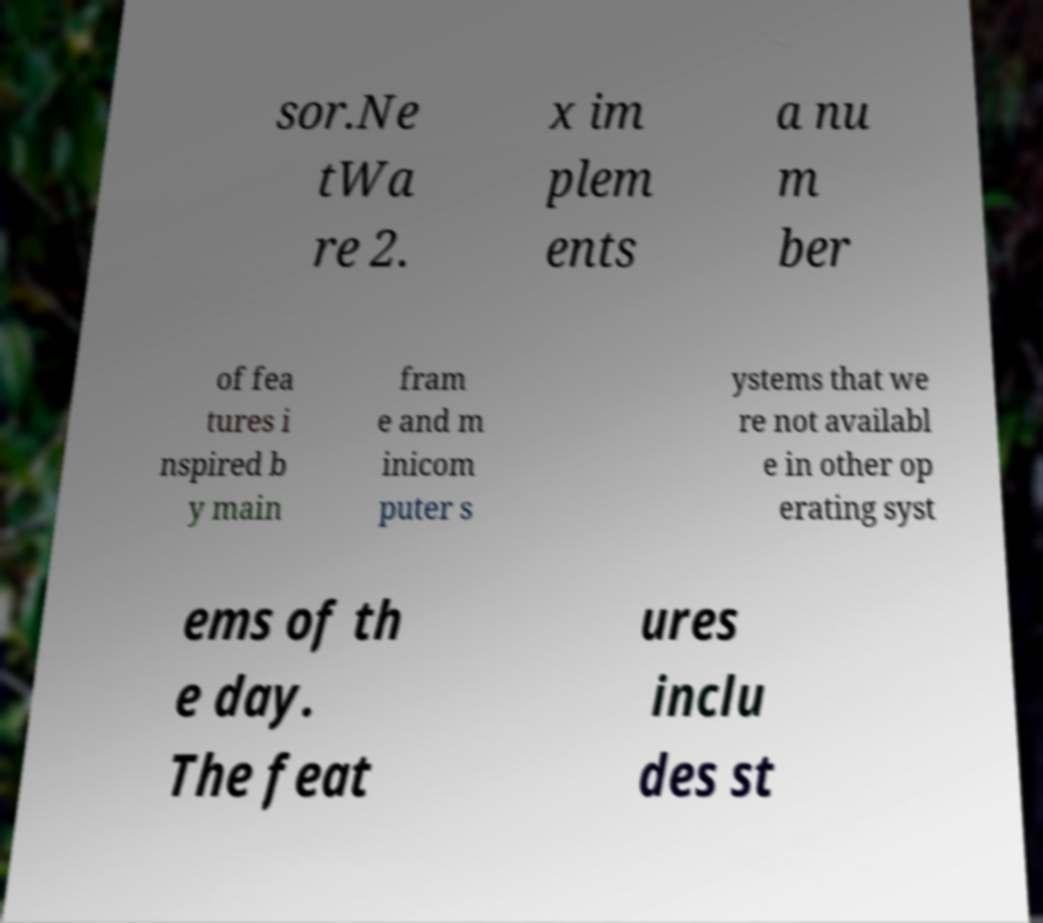There's text embedded in this image that I need extracted. Can you transcribe it verbatim? sor.Ne tWa re 2. x im plem ents a nu m ber of fea tures i nspired b y main fram e and m inicom puter s ystems that we re not availabl e in other op erating syst ems of th e day. The feat ures inclu des st 